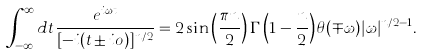Convert formula to latex. <formula><loc_0><loc_0><loc_500><loc_500>\int _ { - \infty } ^ { \infty } d t \frac { e ^ { i \omega t } } { [ - i ( t \pm i o ) ] ^ { n / 2 } } = 2 \sin \left ( \frac { \pi n } { 2 } \right ) \Gamma \left ( 1 - \frac { n } { 2 } \right ) \theta ( \mp \omega ) | \omega | ^ { n / 2 - 1 } .</formula> 